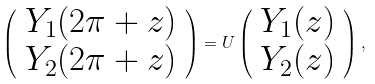Convert formula to latex. <formula><loc_0><loc_0><loc_500><loc_500>\left ( \begin{array} { c } Y _ { 1 } ( 2 \pi + z ) \\ Y _ { 2 } ( 2 \pi + z ) \end{array} \right ) = U \left ( \begin{array} { c } Y _ { 1 } ( z ) \\ Y _ { 2 } ( z ) \end{array} \right ) ,</formula> 